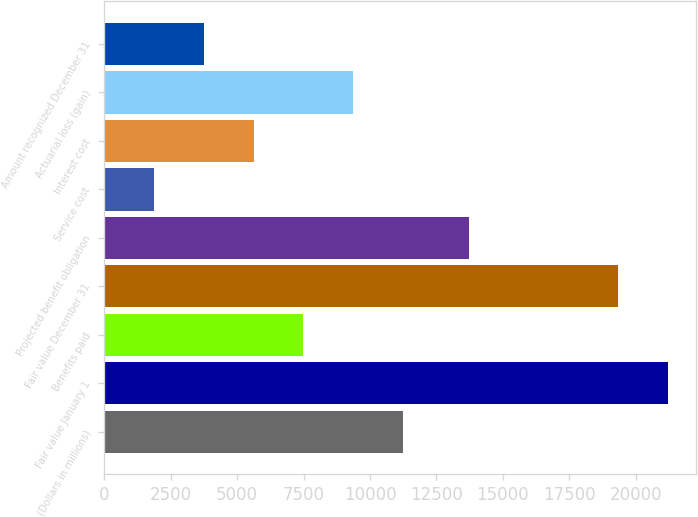Convert chart to OTSL. <chart><loc_0><loc_0><loc_500><loc_500><bar_chart><fcel>(Dollars in millions)<fcel>Fair value January 1<fcel>Benefits paid<fcel>Fair value December 31<fcel>Projected benefit obligation<fcel>Service cost<fcel>Interest cost<fcel>Actuarial loss (gain)<fcel>Amount recognized December 31<nl><fcel>11234.4<fcel>21209.6<fcel>7491.6<fcel>19338.2<fcel>13724<fcel>1877.4<fcel>5620.2<fcel>9363<fcel>3748.8<nl></chart> 